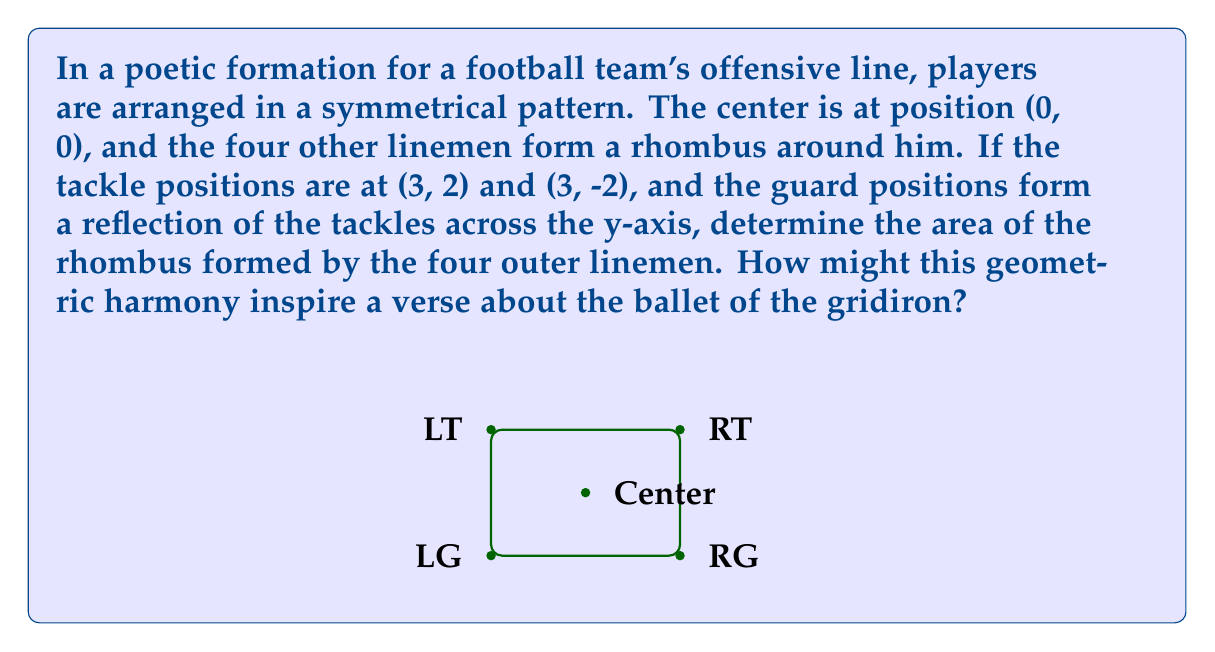Teach me how to tackle this problem. Let's approach this step-by-step:

1) We're given that the tackles are at (3, 2) and (3, -2), and the guards are reflections across the y-axis.

2) This means the guards are at (-3, 2) and (-3, -2).

3) To find the area of a rhombus, we can use the formula:
   $$ \text{Area} = |\text{diagonal}_1 \times \text{diagonal}_2| $$

4) The diagonals of this rhombus are:
   - From (-3, 2) to (3, -2)
   - From (-3, -2) to (3, 2)

5) Let's calculate the length of these diagonals:
   - Diagonal 1: $\sqrt{(3 - (-3))^2 + (-2 - 2)^2} = \sqrt{6^2 + (-4)^2} = \sqrt{52}$
   - Diagonal 2: $\sqrt{(3 - (-3))^2 + (2 - (-2))^2} = \sqrt{6^2 + 4^2} = \sqrt{52}$

6) Now we can apply the formula:
   $$ \text{Area} = |\sqrt{52} \times \sqrt{52}| = 52 $$

7) Therefore, the area of the rhombus is 52 square units.

This geometric symmetry in the football formation mirrors the rhythm and structure often found in poetry. The balanced arrangement of players creates a visual meter, much like the cadence of a well-crafted verse. The rhombus shape, with its equal sides, reflects the equal importance of each player in the line, just as each word in a poem carries its own weight and significance.
Answer: 52 square units 